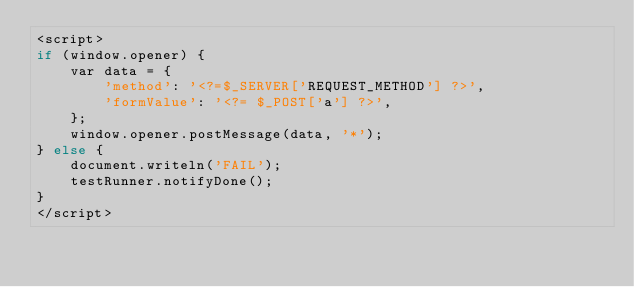Convert code to text. <code><loc_0><loc_0><loc_500><loc_500><_PHP_><script>
if (window.opener) {
    var data = {
        'method': '<?=$_SERVER['REQUEST_METHOD'] ?>',
        'formValue': '<?= $_POST['a'] ?>',
    };
    window.opener.postMessage(data, '*');
} else {
    document.writeln('FAIL');
    testRunner.notifyDone();
}
</script>
</code> 